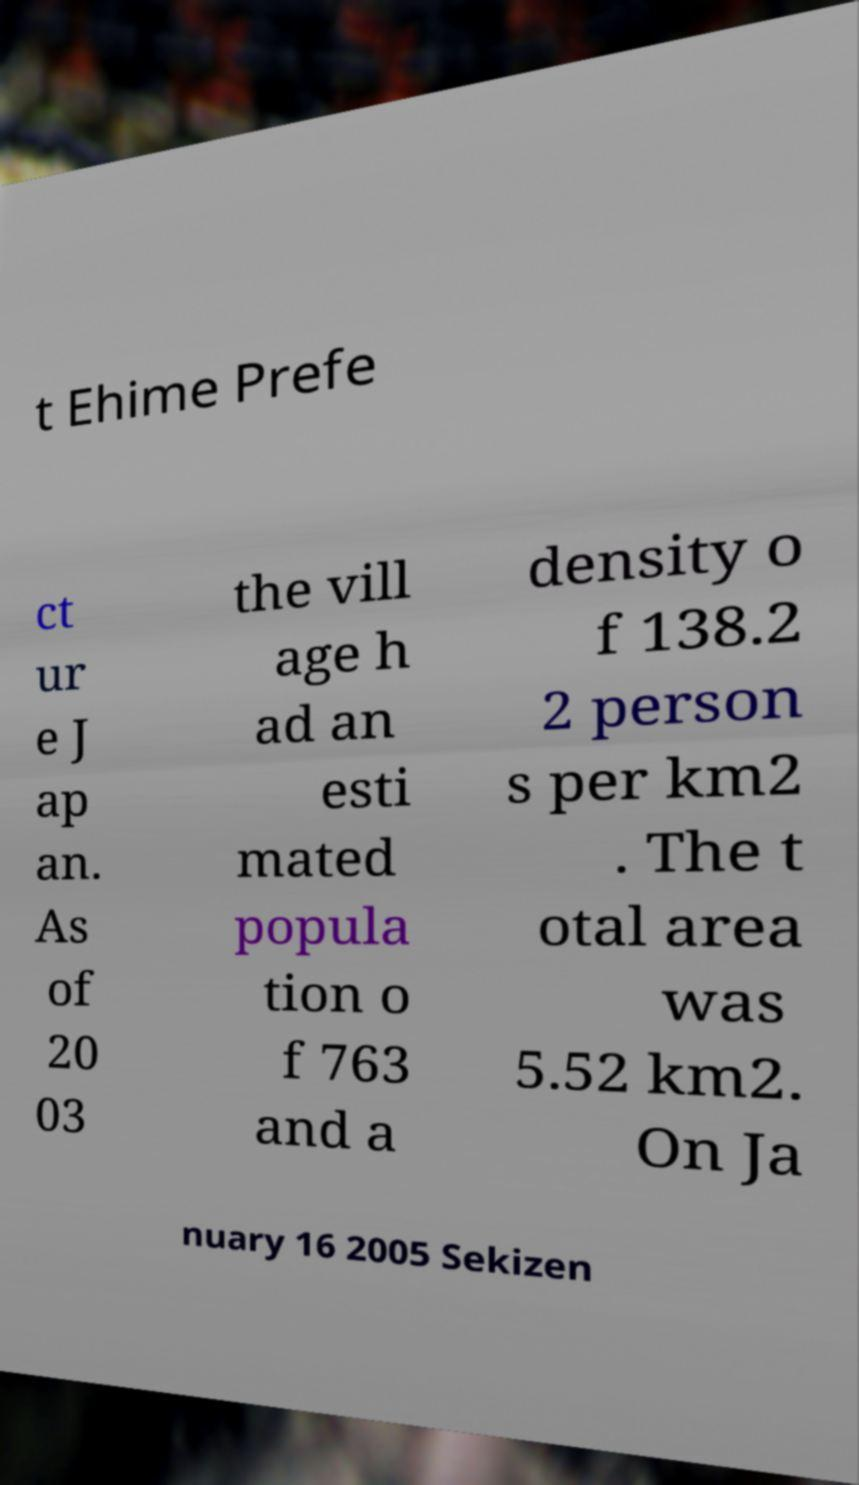What messages or text are displayed in this image? I need them in a readable, typed format. t Ehime Prefe ct ur e J ap an. As of 20 03 the vill age h ad an esti mated popula tion o f 763 and a density o f 138.2 2 person s per km2 . The t otal area was 5.52 km2. On Ja nuary 16 2005 Sekizen 